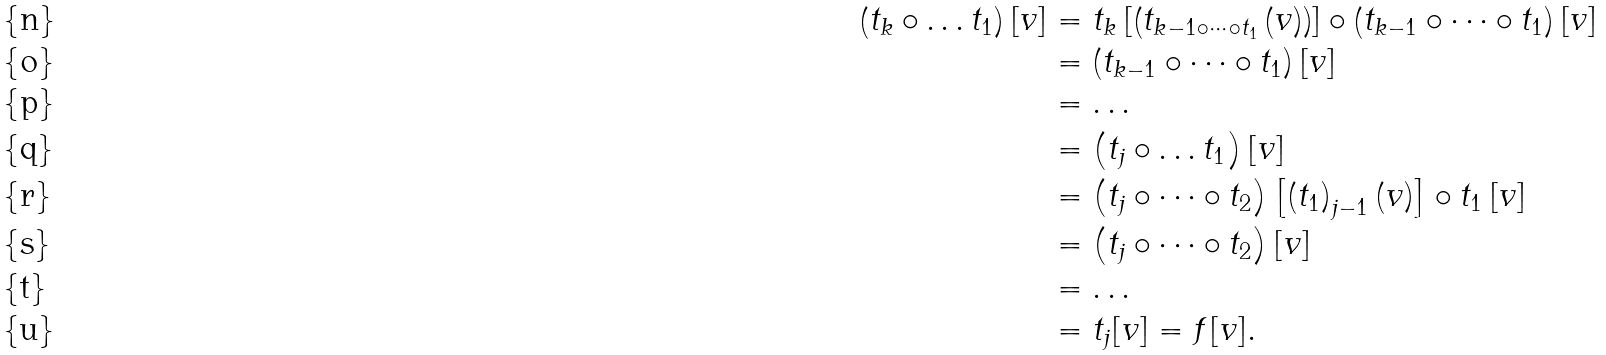Convert formula to latex. <formula><loc_0><loc_0><loc_500><loc_500>\left ( t _ { k } \circ \dots t _ { 1 } \right ) \left [ v \right ] & = t _ { k } \left [ \left ( t _ { k - 1 \circ \dots \circ t _ { 1 } } \left ( v \right ) \right ) \right ] \circ \left ( t _ { k - 1 } \circ \dots \circ t _ { 1 } \right ) [ v ] \\ & = \left ( t _ { k - 1 } \circ \dots \circ t _ { 1 } \right ) [ v ] \\ & = \dots \\ & = \left ( t _ { j } \circ \dots t _ { 1 } \right ) [ v ] \\ & = \left ( t _ { j } \circ \dots \circ t _ { 2 } \right ) \left [ \left ( t _ { 1 } \right ) _ { j - 1 } \left ( v \right ) \right ] \circ t _ { 1 } \left [ v \right ] \\ & = \left ( t _ { j } \circ \dots \circ t _ { 2 } \right ) [ v ] \\ & = \dots \\ & = t _ { j } [ v ] = f [ v ] .</formula> 